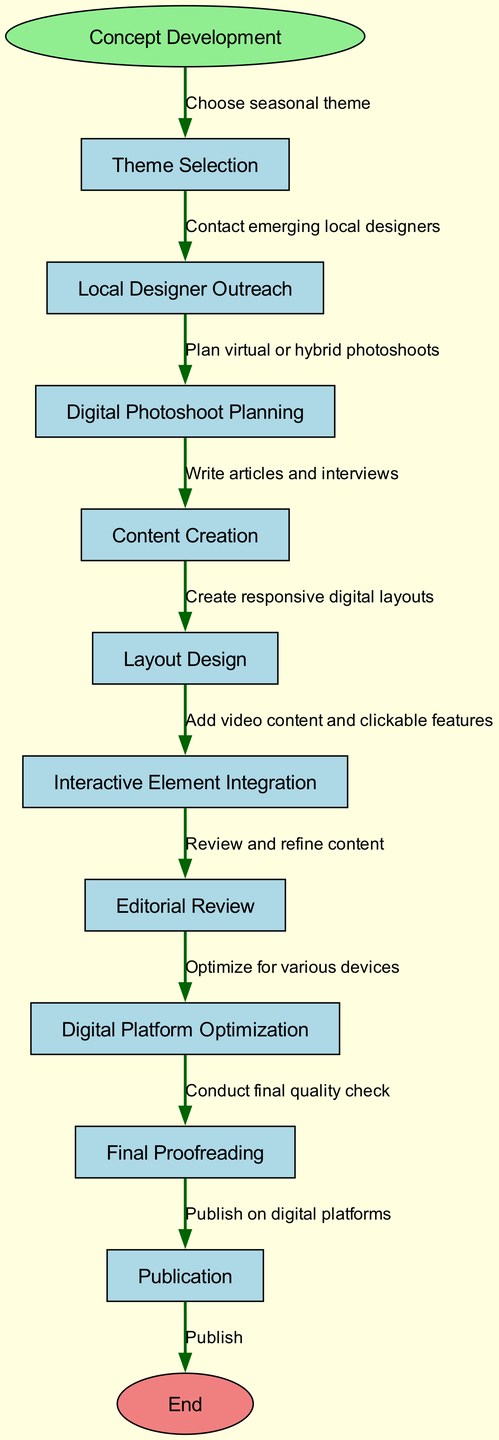What is the starting point of the workflow? The diagram begins with the "Concept Development" node, indicating this is the starting point for the entire process.
Answer: Concept Development How many nodes are in the diagram? The total number of nodes includes the starting point, the ten functional steps, and the end node, giving a total of twelve nodes.
Answer: 12 What follows "Local Designer Outreach"? From the diagram, the next step after "Local Designer Outreach" is "Digital Photoshoot Planning," indicating a sequential process.
Answer: Digital Photoshoot Planning What is the last step before publication? The step directly preceding "Publication" is "Final Proofreading," which ensures content quality before the actual publication occurs.
Answer: Final Proofreading Which node addresses the digital presentation of the magazine? The "Digital Platform Optimization" node focuses on ensuring the magazine is tailored for various devices, thereby addressing digital presentation.
Answer: Digital Platform Optimization What is the relationship between "Theme Selection" and "Content Creation"? The flow from "Theme Selection" to "Content Creation" indicates that selecting a theme is a prerequisite to generating content related to that theme.
Answer: Sequential How many edges connect the nodes? Each step transitions from one action to the next, culminating in ten edges that define the flow from the start to the end of the process.
Answer: 10 What is the purpose of the "Interactive Element Integration" step? This step is intended to enhance the magazine's usability by adding features such as videos or clickable elements, making it more engaging for readers.
Answer: Enhance usability Which step comes after "Layout Design"? "Interactive Element Integration" follows "Layout Design" in the workflow, emphasizing the importance of both layout and interactivity in digital magazines.
Answer: Interactive Element Integration What is the end of the workflow labeled as? The end of the workflow is labeled as "End," indicating the conclusion of the entire process after publishing the magazine.
Answer: End 